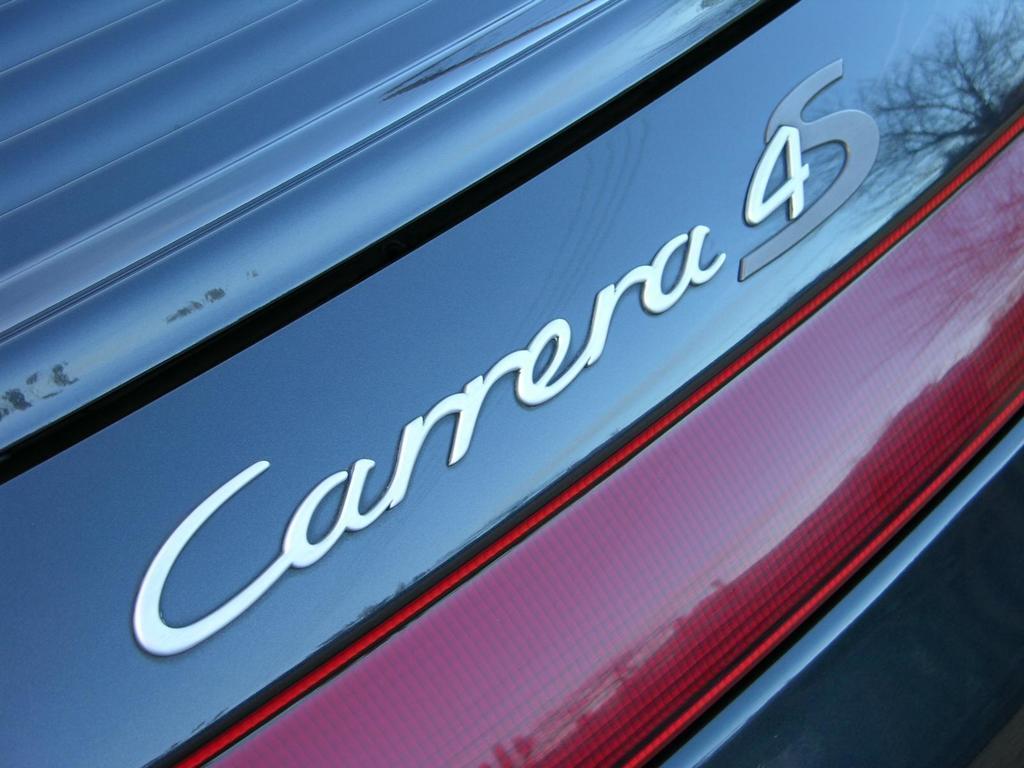How would you summarize this image in a sentence or two? In this picture, it seems like text on a vehicle. 